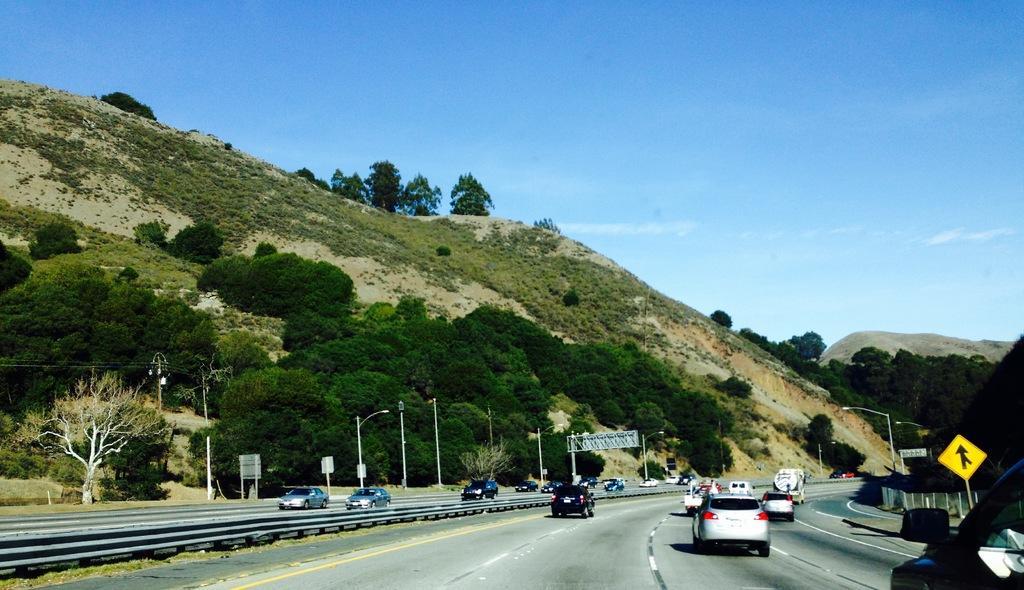Please provide a concise description of this image. In this image we can see a mountain with full of trees. At the bottom we can see vehicles passing on the road. Image also consists of sign boards, light poles and electrical poles with wires. At the top there is sky. 